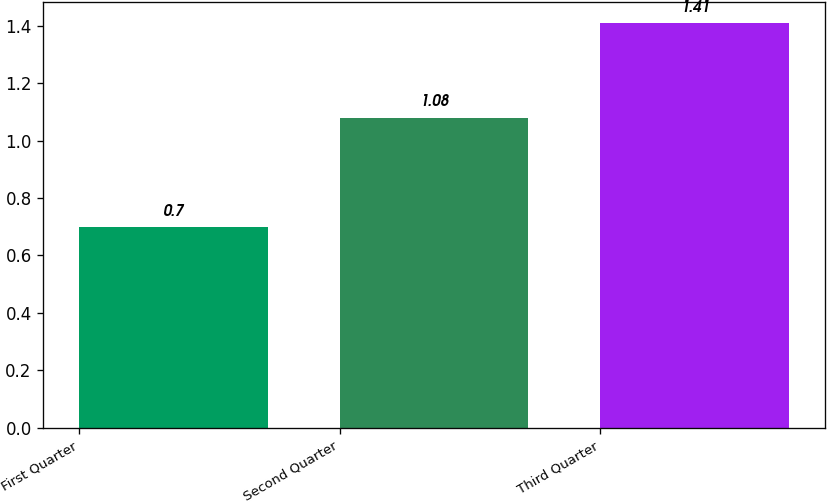Convert chart to OTSL. <chart><loc_0><loc_0><loc_500><loc_500><bar_chart><fcel>First Quarter<fcel>Second Quarter<fcel>Third Quarter<nl><fcel>0.7<fcel>1.08<fcel>1.41<nl></chart> 